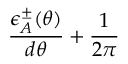<formula> <loc_0><loc_0><loc_500><loc_500>\frac { \epsilon _ { A } ^ { \pm } ( \theta ) } { d \theta } + \frac { 1 } { 2 \pi }</formula> 